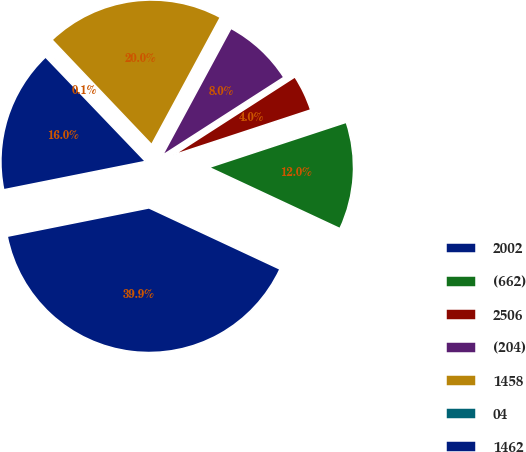Convert chart to OTSL. <chart><loc_0><loc_0><loc_500><loc_500><pie_chart><fcel>2002<fcel>(662)<fcel>2506<fcel>(204)<fcel>1458<fcel>04<fcel>1462<nl><fcel>39.9%<fcel>12.01%<fcel>4.04%<fcel>8.02%<fcel>19.98%<fcel>0.05%<fcel>15.99%<nl></chart> 